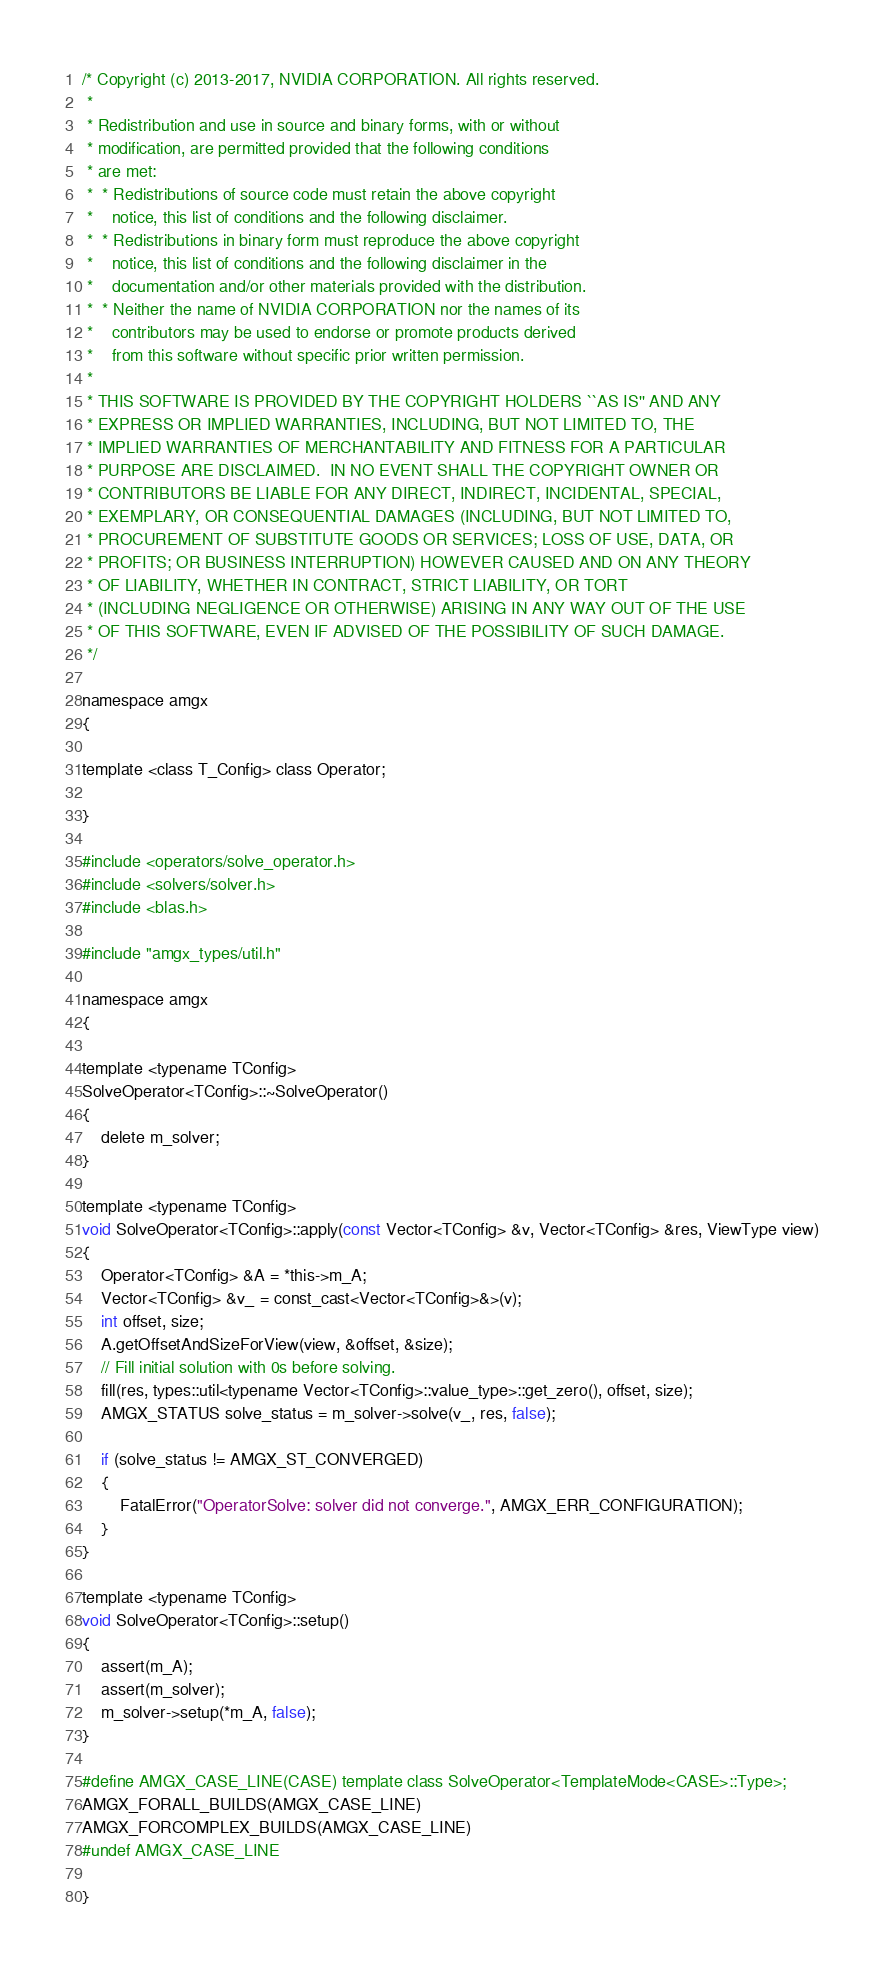<code> <loc_0><loc_0><loc_500><loc_500><_Cuda_>/* Copyright (c) 2013-2017, NVIDIA CORPORATION. All rights reserved.
 *
 * Redistribution and use in source and binary forms, with or without
 * modification, are permitted provided that the following conditions
 * are met:
 *  * Redistributions of source code must retain the above copyright
 *    notice, this list of conditions and the following disclaimer.
 *  * Redistributions in binary form must reproduce the above copyright
 *    notice, this list of conditions and the following disclaimer in the
 *    documentation and/or other materials provided with the distribution.
 *  * Neither the name of NVIDIA CORPORATION nor the names of its
 *    contributors may be used to endorse or promote products derived
 *    from this software without specific prior written permission.
 *
 * THIS SOFTWARE IS PROVIDED BY THE COPYRIGHT HOLDERS ``AS IS'' AND ANY
 * EXPRESS OR IMPLIED WARRANTIES, INCLUDING, BUT NOT LIMITED TO, THE
 * IMPLIED WARRANTIES OF MERCHANTABILITY AND FITNESS FOR A PARTICULAR
 * PURPOSE ARE DISCLAIMED.  IN NO EVENT SHALL THE COPYRIGHT OWNER OR
 * CONTRIBUTORS BE LIABLE FOR ANY DIRECT, INDIRECT, INCIDENTAL, SPECIAL,
 * EXEMPLARY, OR CONSEQUENTIAL DAMAGES (INCLUDING, BUT NOT LIMITED TO,
 * PROCUREMENT OF SUBSTITUTE GOODS OR SERVICES; LOSS OF USE, DATA, OR
 * PROFITS; OR BUSINESS INTERRUPTION) HOWEVER CAUSED AND ON ANY THEORY
 * OF LIABILITY, WHETHER IN CONTRACT, STRICT LIABILITY, OR TORT
 * (INCLUDING NEGLIGENCE OR OTHERWISE) ARISING IN ANY WAY OUT OF THE USE
 * OF THIS SOFTWARE, EVEN IF ADVISED OF THE POSSIBILITY OF SUCH DAMAGE.
 */

namespace amgx
{

template <class T_Config> class Operator;

}

#include <operators/solve_operator.h>
#include <solvers/solver.h>
#include <blas.h>

#include "amgx_types/util.h"

namespace amgx
{

template <typename TConfig>
SolveOperator<TConfig>::~SolveOperator()
{
    delete m_solver;
}

template <typename TConfig>
void SolveOperator<TConfig>::apply(const Vector<TConfig> &v, Vector<TConfig> &res, ViewType view)
{
    Operator<TConfig> &A = *this->m_A;
    Vector<TConfig> &v_ = const_cast<Vector<TConfig>&>(v);
    int offset, size;
    A.getOffsetAndSizeForView(view, &offset, &size);
    // Fill initial solution with 0s before solving.
    fill(res, types::util<typename Vector<TConfig>::value_type>::get_zero(), offset, size);
    AMGX_STATUS solve_status = m_solver->solve(v_, res, false);

    if (solve_status != AMGX_ST_CONVERGED)
    {
        FatalError("OperatorSolve: solver did not converge.", AMGX_ERR_CONFIGURATION);
    }
}

template <typename TConfig>
void SolveOperator<TConfig>::setup()
{
    assert(m_A);
    assert(m_solver);
    m_solver->setup(*m_A, false);
}

#define AMGX_CASE_LINE(CASE) template class SolveOperator<TemplateMode<CASE>::Type>;
AMGX_FORALL_BUILDS(AMGX_CASE_LINE)
AMGX_FORCOMPLEX_BUILDS(AMGX_CASE_LINE)
#undef AMGX_CASE_LINE

}
</code> 